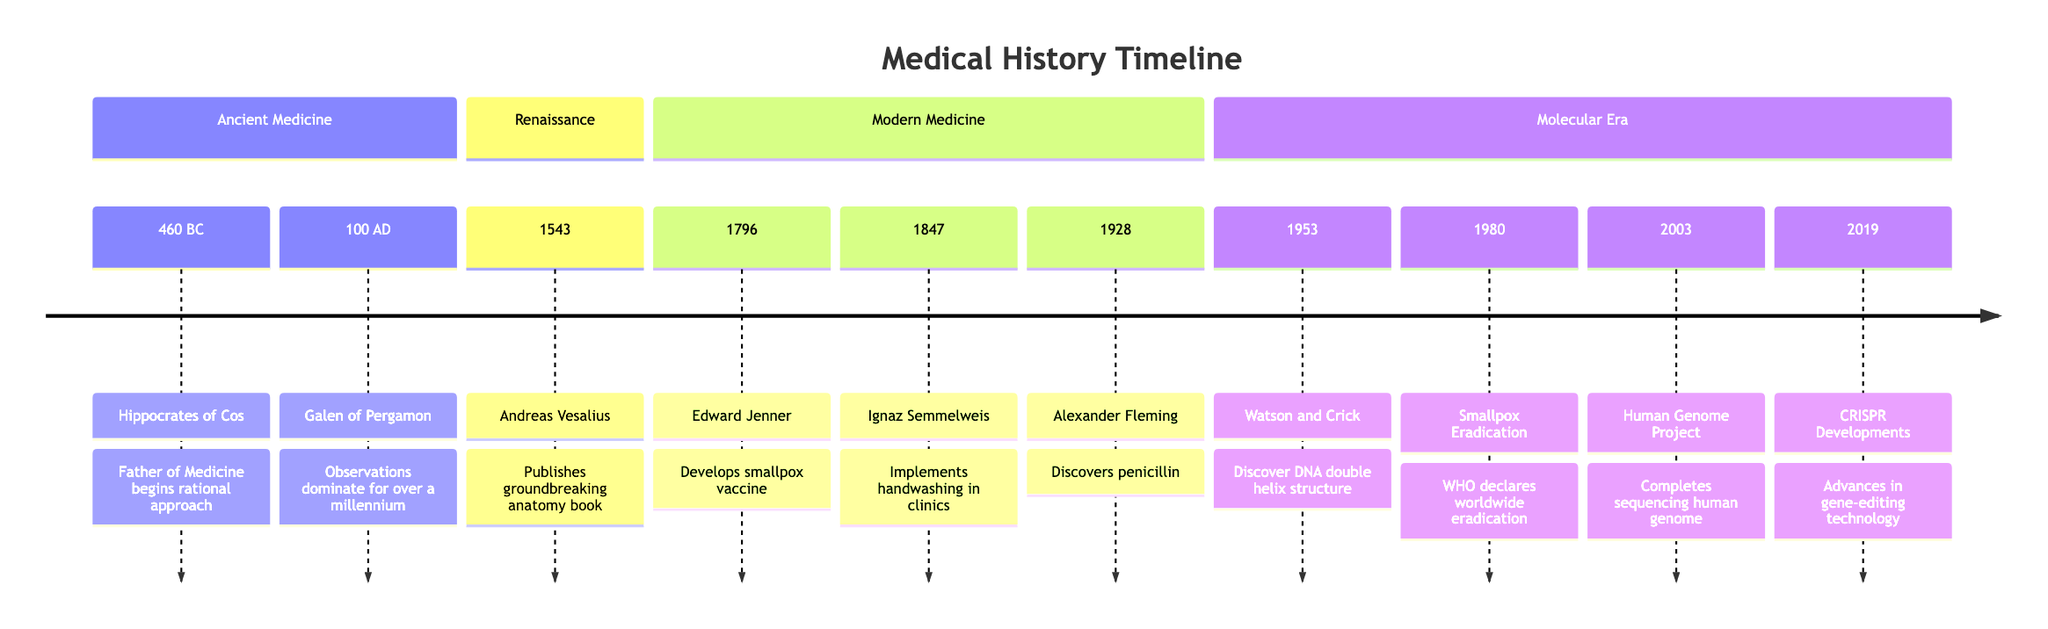What year did Hippocrates practice medicine? The diagram states that Hippocrates of Cos began practicing medicine in 460 BC.
Answer: 460 BC What major development occurred in 1796? According to the timeline, Edward Jenner developed the smallpox vaccine in 1796, a significant advancement in medicine.
Answer: Smallpox vaccine How many events are listed in the Modern Medicine section? The diagram shows three events under the Modern Medicine section: the smallpox vaccine in 1796, handwashing in 1847, and the discovery of penicillin in 1928. Therefore, we count them as three events.
Answer: 3 Which event represents a significant development in genetics? The timeline indicates that Watson and Crick's discovery of the DNA double helix structure in 1953 marks a major milestone in genetics and molecular biology.
Answer: DNA double helix structure In what year was smallpox declared eradicated? According to the timeline, the World Health Organization declared smallpox eradicated in 1980.
Answer: 1980 What advances were made in 2019? The diagram specifies that there were advancements in CRISPR gene-editing technology in 2019, showing a progression in potential treatments for genetic disorders.
Answer: CRISPR Developments Which two figures are associated with ancient medicine? The timeline lists Hippocrates of Cos (460 BC) and Galen of Pergamon (100 AD) as key figures in ancient medicine. Both contributed significantly to medical practices of their time.
Answer: Hippocrates and Galen What is the earliest event shown in the timeline? The diagram indicates that the earliest event listed is Hippocrates practicing medicine in 460 BC.
Answer: 460 BC How did Ignaz Semmelweis's contribution impact medicine? According to the timeline, Semmelweis's implementation of handwashing in obstetric clinics significantly reduced infant mortality rates, highlighting an essential public health measure.
Answer: Reduced infant mortality rates 